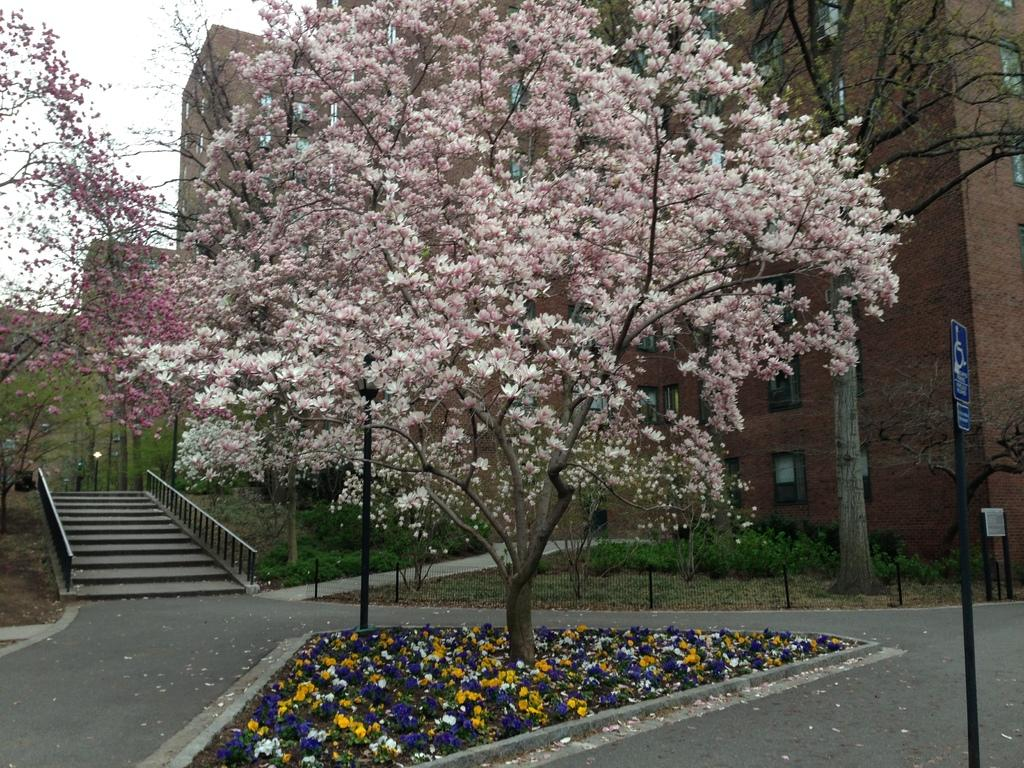What type of vegetation can be seen in the image? There are trees in the image. What is a notable feature of the trees? The trees have blossoms. What can be seen in the background of the image? There are buildings and boards visible in the background. What part of the sky is visible in the image? The sky is visible in the background. What architectural feature is located on the left side of the image? There are stairs on the left side of the image. Can you tell me how many streams are visible in the image? There are no streams present in the image. What type of wash is being used to clean the cellar in the image? There is no cellar or wash present in the image. 